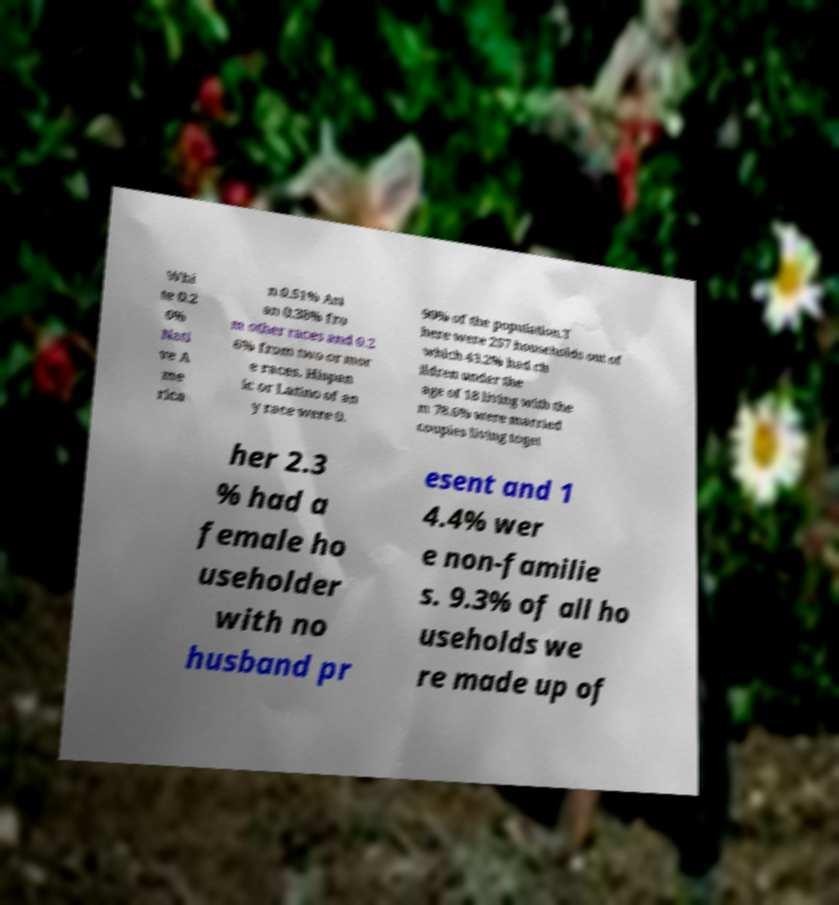What messages or text are displayed in this image? I need them in a readable, typed format. Whi te 0.2 6% Nati ve A me rica n 0.51% Asi an 0.38% fro m other races and 0.2 6% from two or mor e races. Hispan ic or Latino of an y race were 0. 90% of the population.T here were 257 households out of which 43.2% had ch ildren under the age of 18 living with the m 78.6% were married couples living toget her 2.3 % had a female ho useholder with no husband pr esent and 1 4.4% wer e non-familie s. 9.3% of all ho useholds we re made up of 